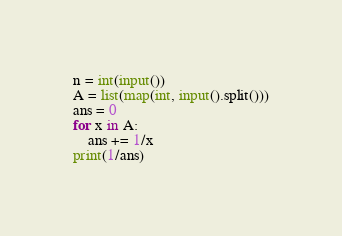<code> <loc_0><loc_0><loc_500><loc_500><_Python_>n = int(input())
A = list(map(int, input().split()))
ans = 0
for x in A:
    ans += 1/x
print(1/ans)</code> 